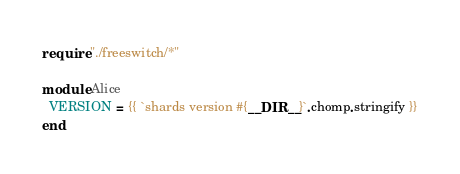<code> <loc_0><loc_0><loc_500><loc_500><_Crystal_>require "./freeswitch/*"

module Alice
  VERSION = {{ `shards version #{__DIR__}`.chomp.stringify }}
end
</code> 